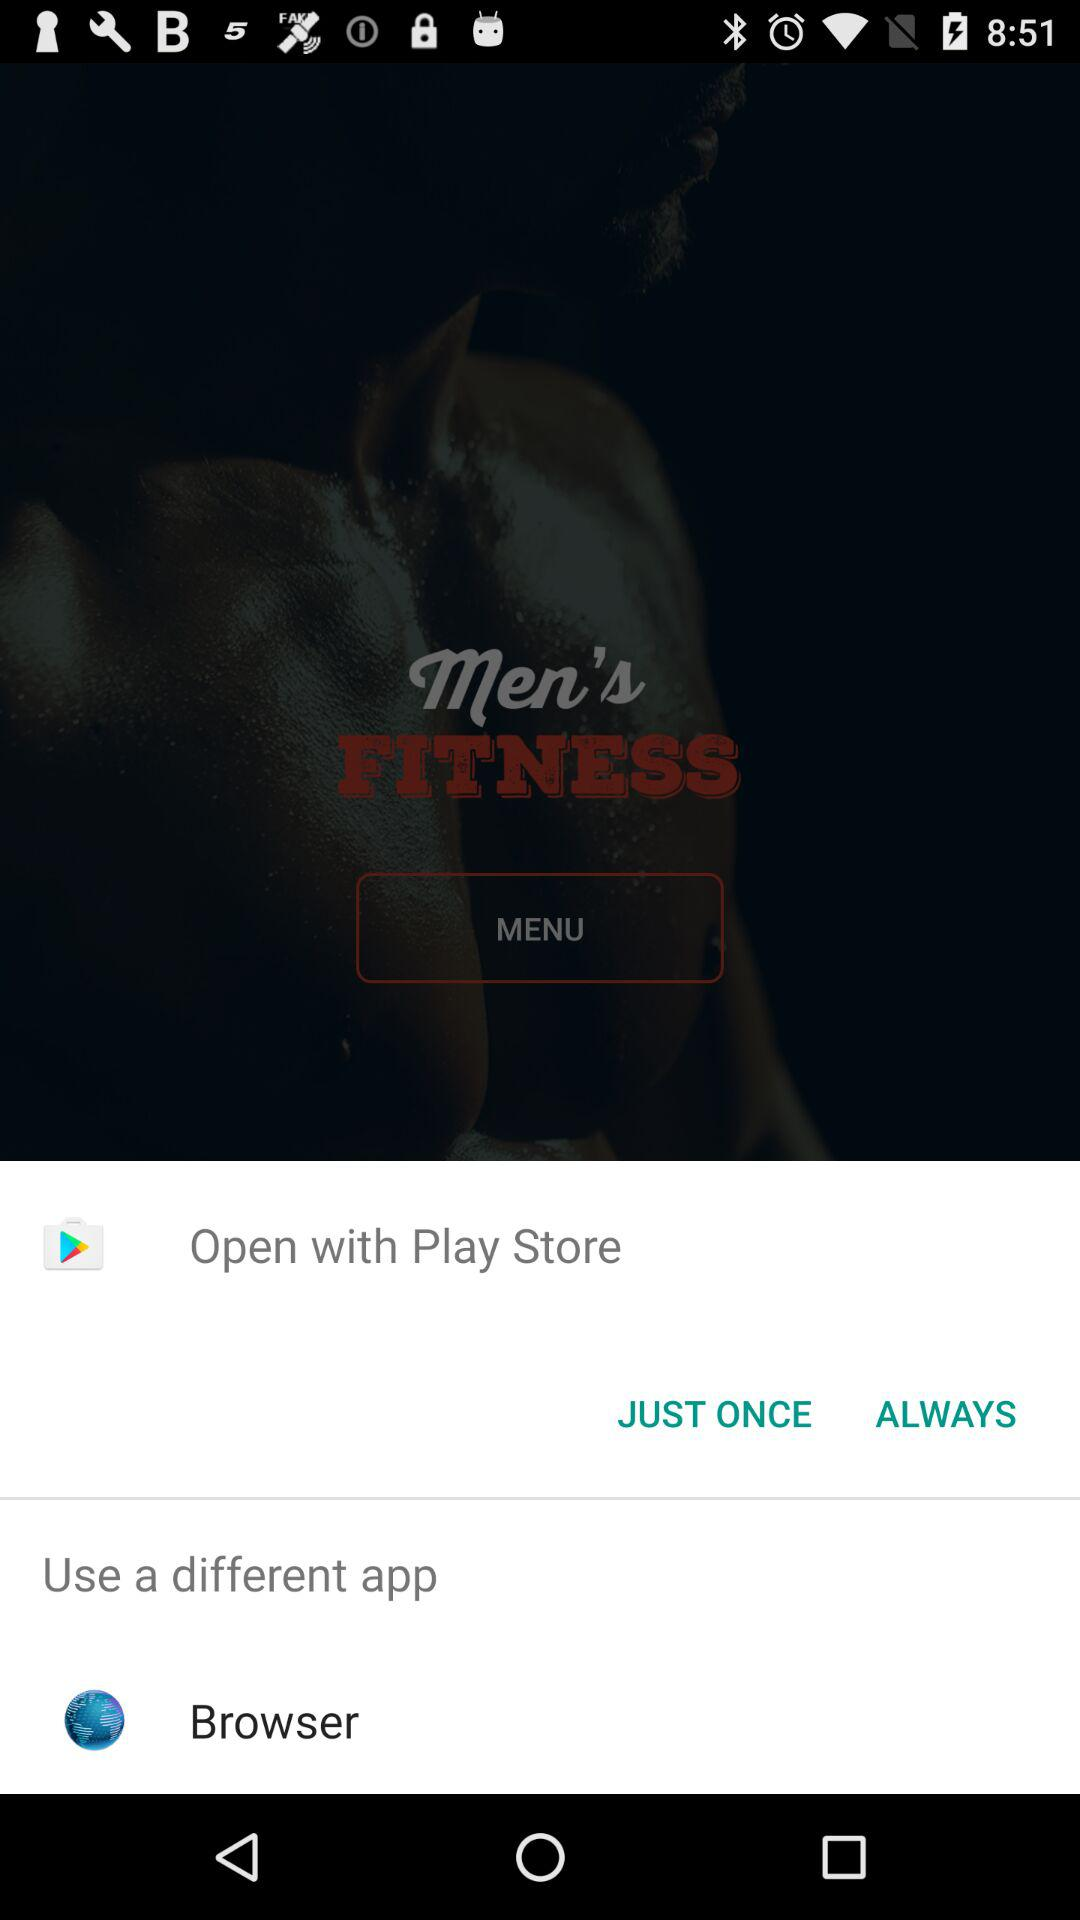What is the given different application option? The different application option given is "Browser". 